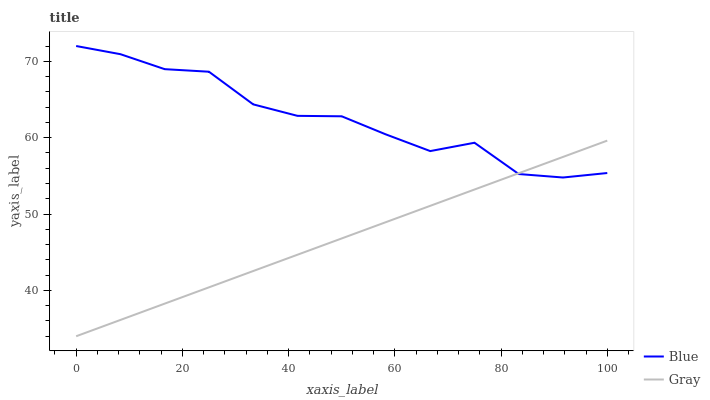Does Gray have the maximum area under the curve?
Answer yes or no. No. Is Gray the roughest?
Answer yes or no. No. Does Gray have the highest value?
Answer yes or no. No. 